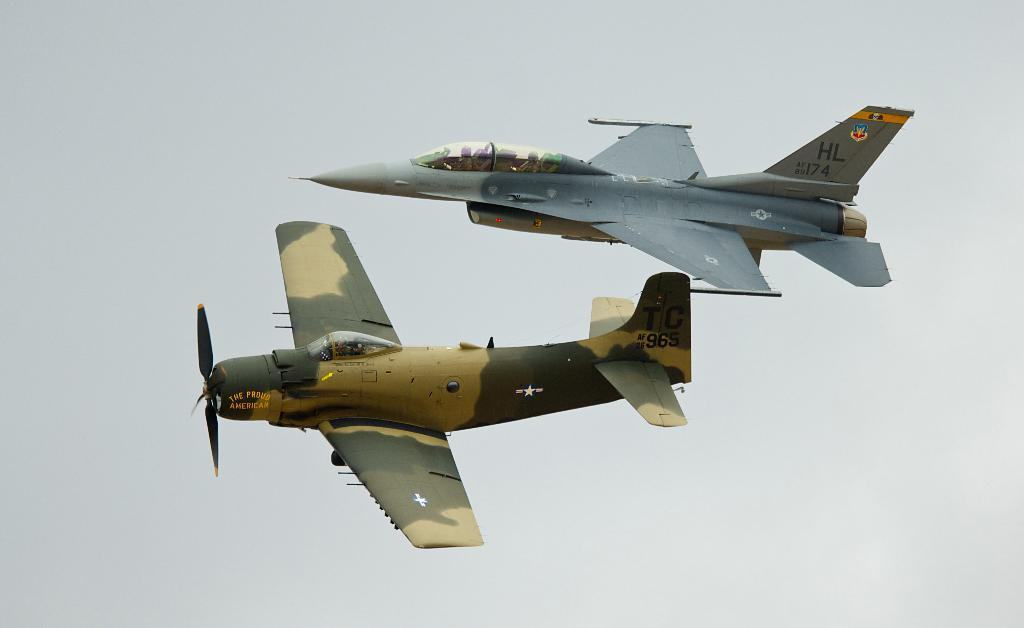What type of aircraft is present in the image? There is a fighter jet and another aircraft in the image. What are the aircraft doing in the image? Both the fighter jet and the aircraft are flying in the air. What is the condition of the sky in the image? The sky is cloudy in the image. What type of pot is visible in the image? There is no pot present in the image; it features a fighter jet and another aircraft flying in the sky. How does the fighter jet sneeze in the image? Aircraft, including fighter jets, do not have the ability to sneeze, as they are inanimate objects. 